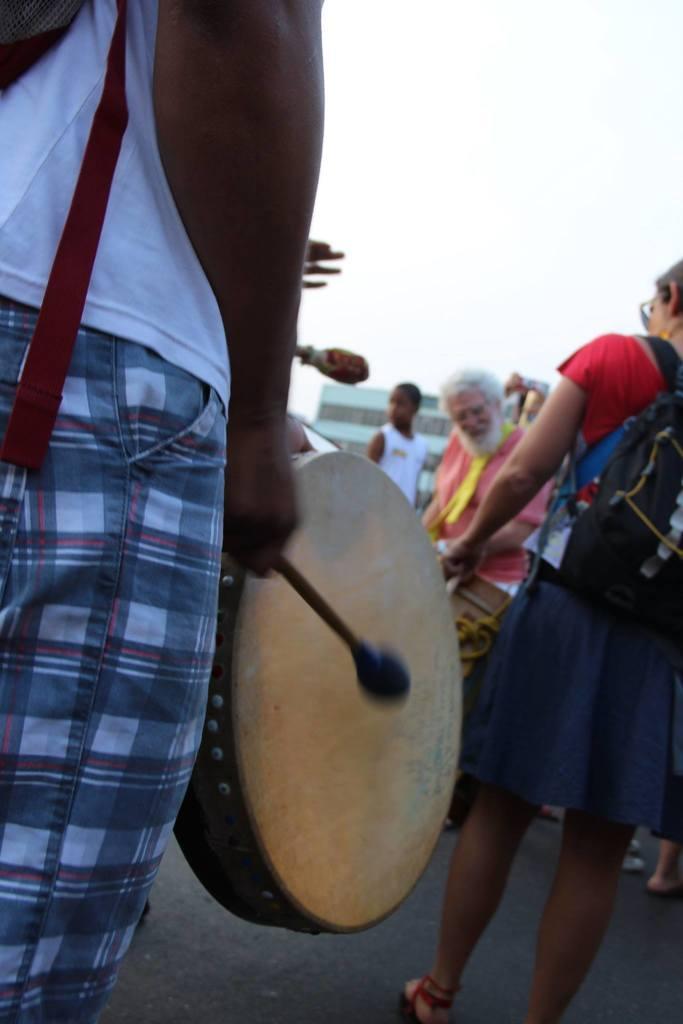In one or two sentences, can you explain what this image depicts? In this picture we can see some people are standing, a person on the left side is playing a drum, a person on the right side is carrying a bag, in the background it looks like a building, there is the sky at the top of the picture. 